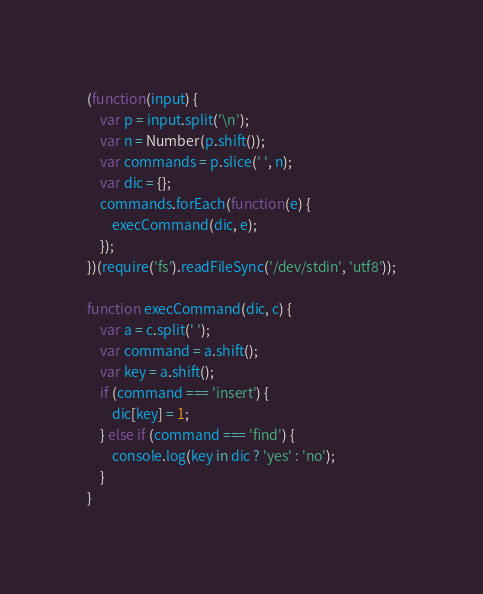<code> <loc_0><loc_0><loc_500><loc_500><_JavaScript_>(function(input) {
    var p = input.split('\n');
    var n = Number(p.shift());
    var commands = p.slice(' ', n);
    var dic = {};
    commands.forEach(function(e) {
        execCommand(dic, e);
    });
})(require('fs').readFileSync('/dev/stdin', 'utf8'));

function execCommand(dic, c) {
    var a = c.split(' ');
    var command = a.shift();
    var key = a.shift();
    if (command === 'insert') {
        dic[key] = 1;
    } else if (command === 'find') {
        console.log(key in dic ? 'yes' : 'no');
    }
}</code> 